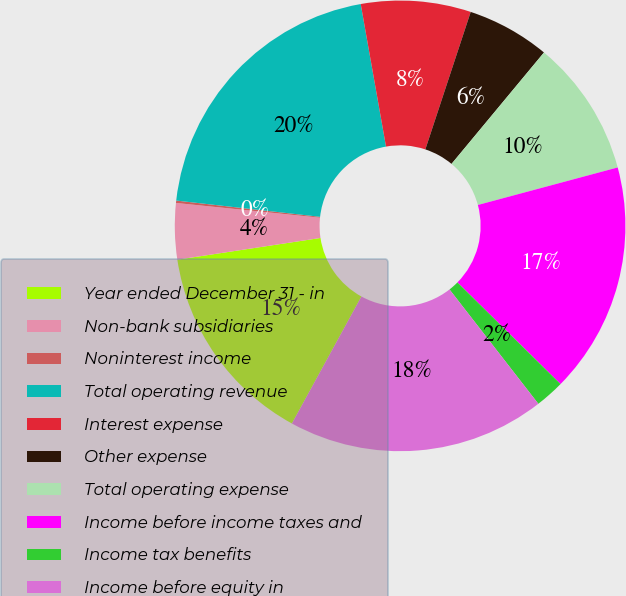Convert chart to OTSL. <chart><loc_0><loc_0><loc_500><loc_500><pie_chart><fcel>Year ended December 31 - in<fcel>Non-bank subsidiaries<fcel>Noninterest income<fcel>Total operating revenue<fcel>Interest expense<fcel>Other expense<fcel>Total operating expense<fcel>Income before income taxes and<fcel>Income tax benefits<fcel>Income before equity in<nl><fcel>14.63%<fcel>4.02%<fcel>0.17%<fcel>20.41%<fcel>7.87%<fcel>5.95%<fcel>9.8%<fcel>16.56%<fcel>2.1%<fcel>18.48%<nl></chart> 